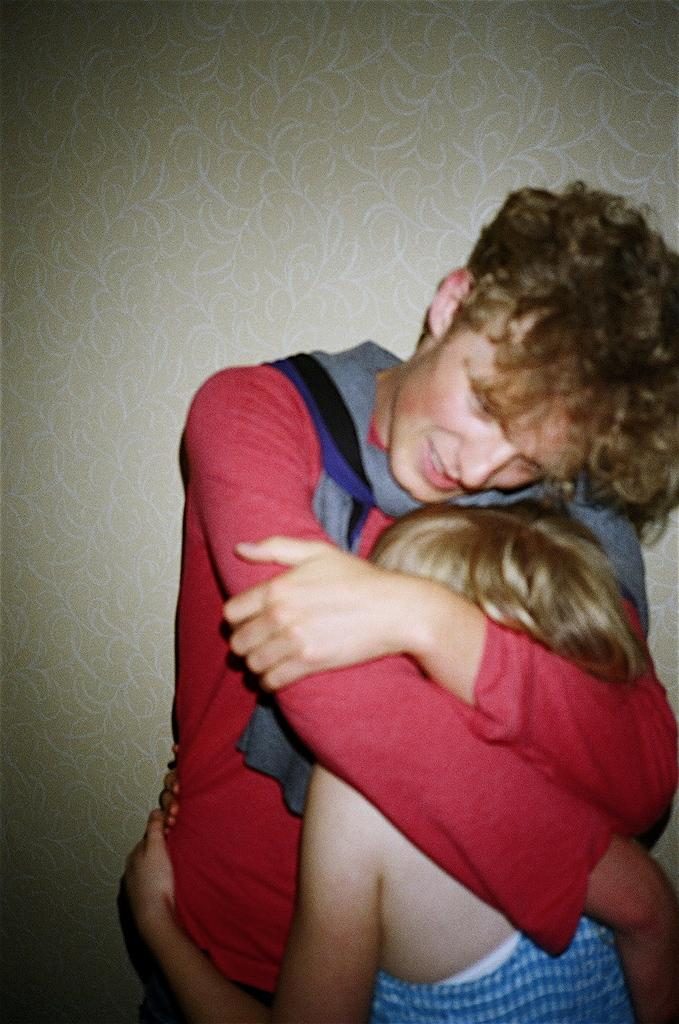How many people are in the image? There are two people in the foreground of the image. What are the two people doing in the image? The two people are standing and hugging each other. What can be seen in the background of the image? There is a wall in the background of the image. What is on the wall in the background? There is some art on the wall in the background. What type of paste is being used by the people in the image? There is no paste being used by the people in the image; they are simply hugging each other. What is the mindset of the people in the image? The provided facts do not give any information about the mindset of the people in the image. 